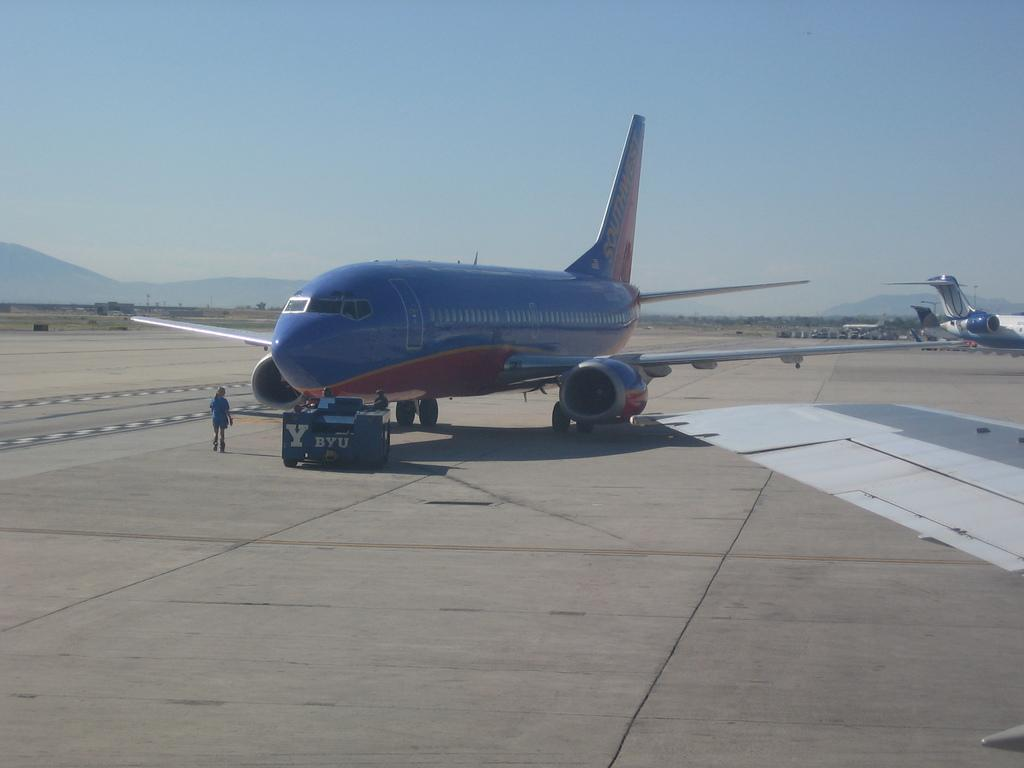What type of vehicles are on the ground in the image? There are airplanes on the ground in the image. Can you describe the people visible in the image? There are people visible in the image, but their specific actions or characteristics are not mentioned in the provided facts. What can be seen in the background of the image? Objects, mountains, and the sky are visible in the background of the image. What type of sweater is the airplane wearing in the image? Airplanes do not wear sweaters, as they are inanimate objects. 